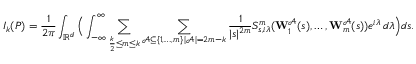Convert formula to latex. <formula><loc_0><loc_0><loc_500><loc_500>I _ { k } ( P ) = \frac { 1 } { 2 \pi } \int _ { \mathbb { R } ^ { d } } \left ( \int _ { - \infty } ^ { \infty } \sum _ { \frac { k } { 2 } \leq m \leq k } \sum _ { \substack { \ m a t h s c r { A } \subseteq \{ 1 , \dots , m \} \, | \ m a t h s c r { A } | = 2 m - k } } \frac { 1 } { | s | ^ { 2 m } } S _ { s , i \lambda } ^ { m } ( W _ { 1 } ^ { \ m a t h s c r { A } } ( s ) , \dots , W _ { m } ^ { \ m a t h s c r { A } } ( s ) ) e ^ { i \lambda } \, d \lambda \right ) d s .</formula> 